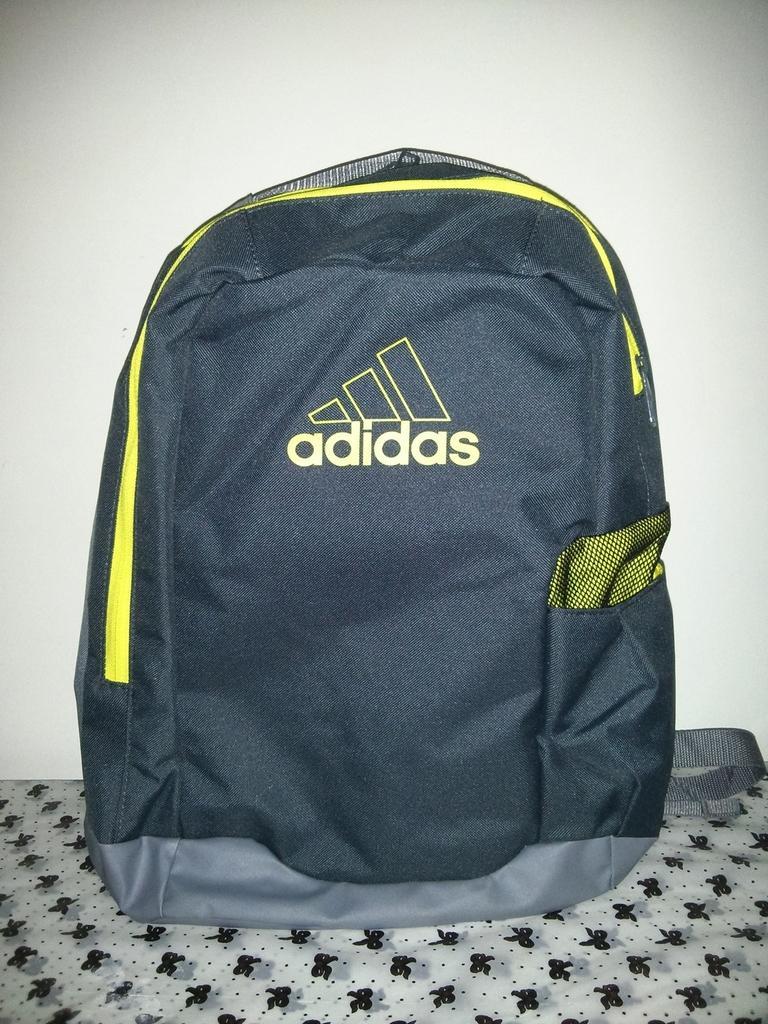How would you summarize this image in a sentence or two? In this picture on the foreground there is a couch, on the couch there is a Adidas bag. Background there is a wall painted in white. 